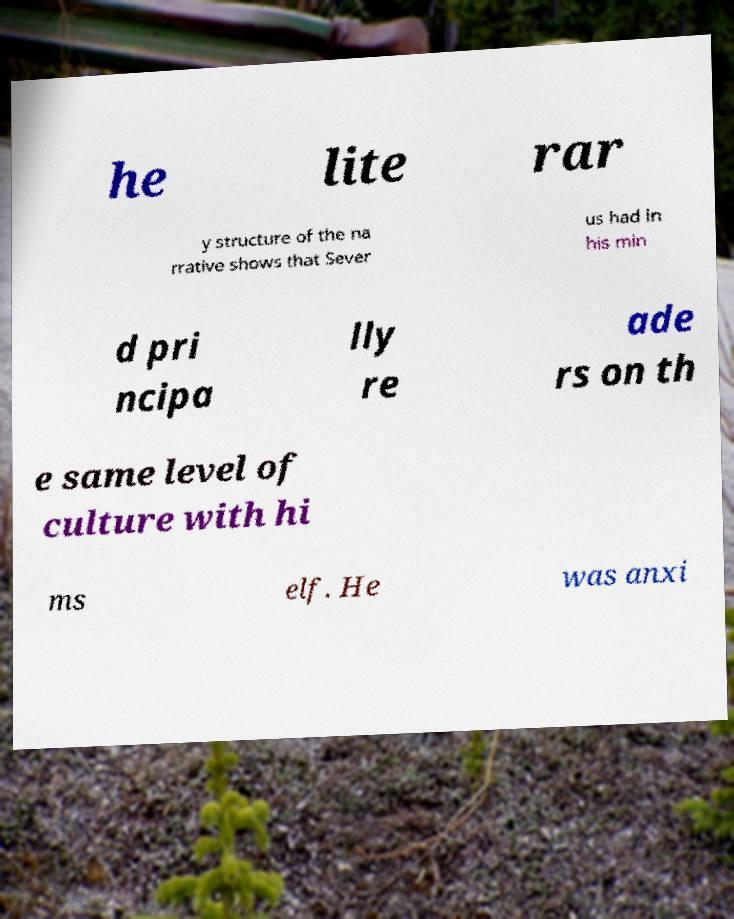I need the written content from this picture converted into text. Can you do that? he lite rar y structure of the na rrative shows that Sever us had in his min d pri ncipa lly re ade rs on th e same level of culture with hi ms elf. He was anxi 